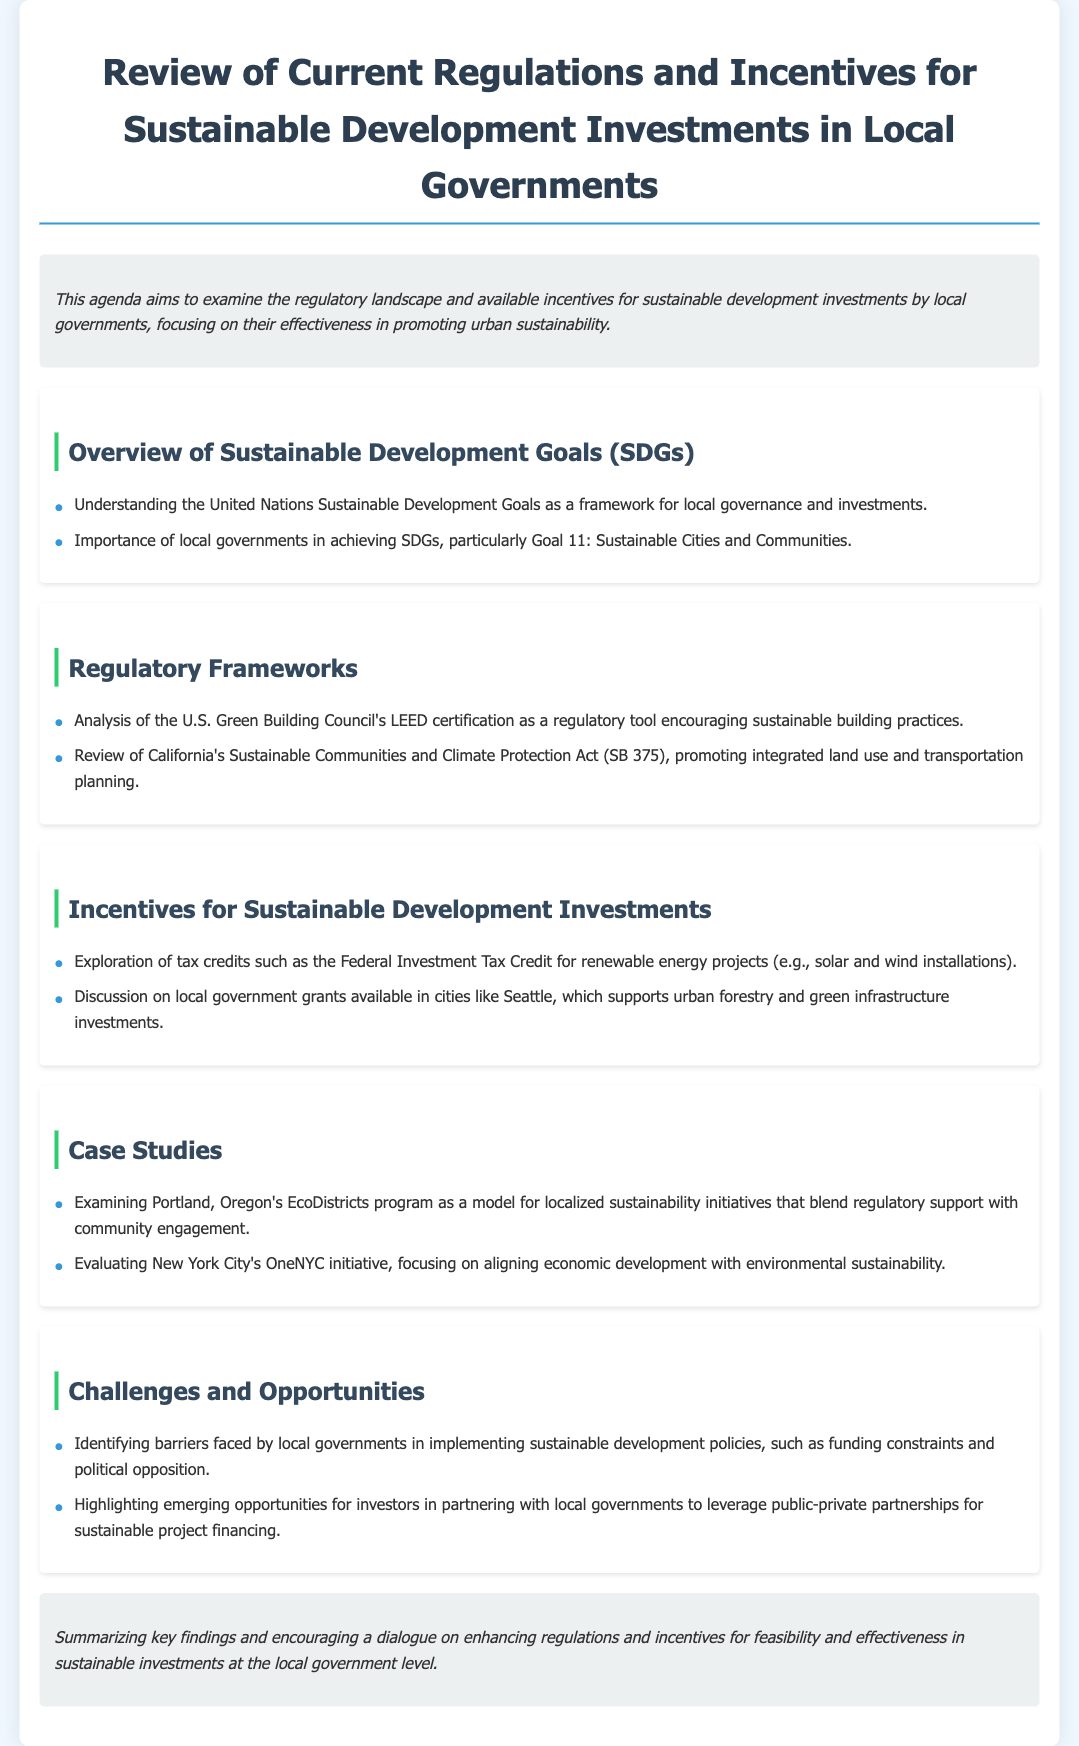What is the title of the agenda? The title is explicitly mentioned at the beginning of the document.
Answer: Review of Current Regulations and Incentives for Sustainable Development Investments in Local Governments What are the Sustainable Development Goals abbreviated as? The document refers to them by their abbreviation.
Answer: SDGs Which organization’s LEED certification is mentioned? The document specifies an organization related to sustainable building practices.
Answer: U.S. Green Building Council What state's Sustainable Communities and Climate Protection Act is reviewed? The document specifies the state related to climate protection regulations.
Answer: California Which city provides local government grants for urban forestry? The document lists a city known for its specific grants.
Answer: Seattle What program is examined in Portland, Oregon? The document identifies a specific sustainability initiative in Portland.
Answer: EcoDistricts program What initiative is evaluated in New York City? The document mentions a specific sustainability initiative in New York City.
Answer: OneNYC initiative What barrier to sustainable development policies is identified? The document notes a common issue faced by local governments.
Answer: Funding constraints What opportunity for investors is highlighted in the challenges? The document points out a potential area for investor participation.
Answer: Public-private partnerships 